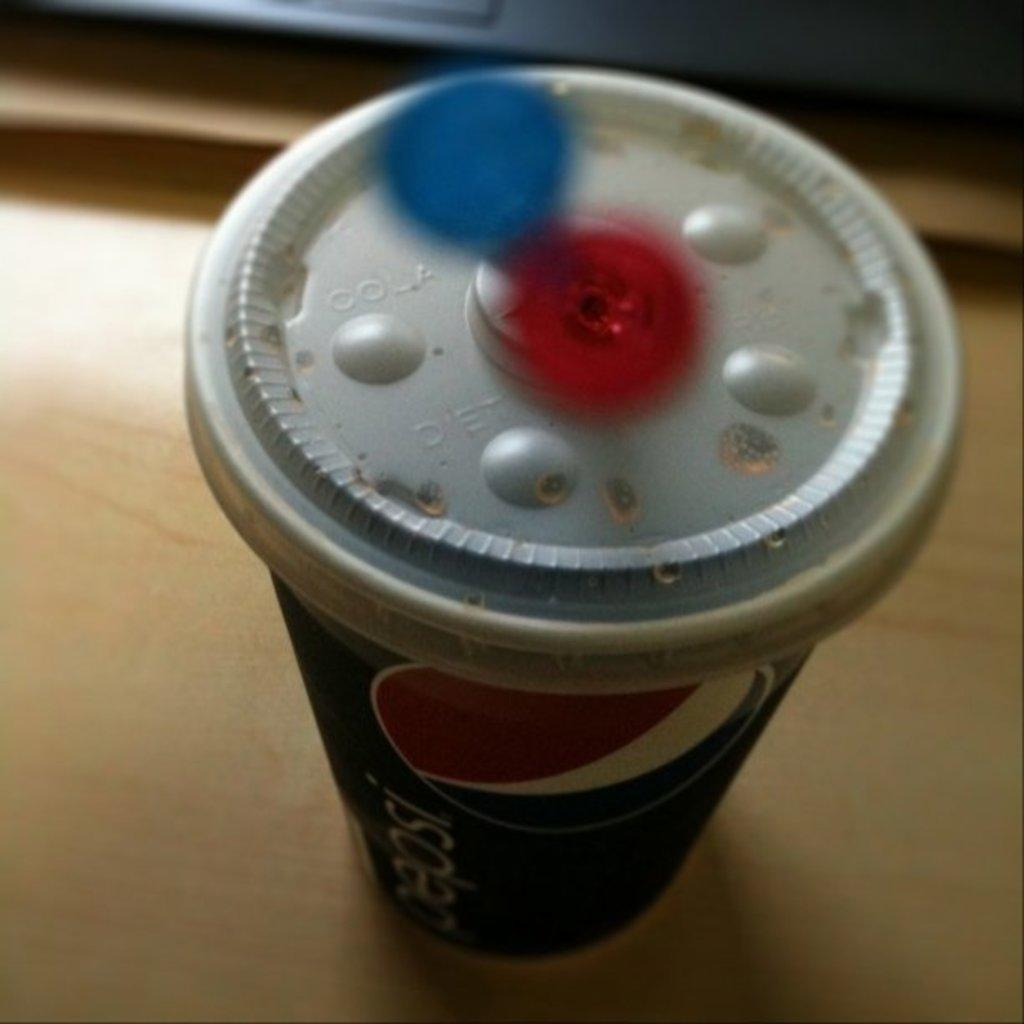<image>
Give a short and clear explanation of the subsequent image. A paper cup with the word Pepsi printed on its side and a plastic lid on top of it sits on a desk. 